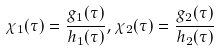<formula> <loc_0><loc_0><loc_500><loc_500>\chi _ { 1 } ( \tau ) = \frac { g _ { 1 } ( \tau ) } { h _ { 1 } ( \tau ) } , \chi _ { 2 } ( \tau ) = \frac { g _ { 2 } ( \tau ) } { h _ { 2 } ( \tau ) }</formula> 